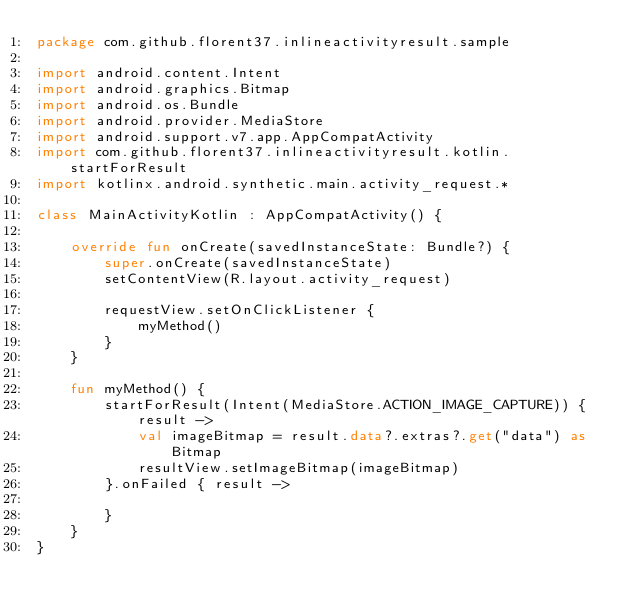<code> <loc_0><loc_0><loc_500><loc_500><_Kotlin_>package com.github.florent37.inlineactivityresult.sample

import android.content.Intent
import android.graphics.Bitmap
import android.os.Bundle
import android.provider.MediaStore
import android.support.v7.app.AppCompatActivity
import com.github.florent37.inlineactivityresult.kotlin.startForResult
import kotlinx.android.synthetic.main.activity_request.*

class MainActivityKotlin : AppCompatActivity() {

    override fun onCreate(savedInstanceState: Bundle?) {
        super.onCreate(savedInstanceState)
        setContentView(R.layout.activity_request)

        requestView.setOnClickListener {
            myMethod()
        }
    }

    fun myMethod() {
        startForResult(Intent(MediaStore.ACTION_IMAGE_CAPTURE)) { result ->
            val imageBitmap = result.data?.extras?.get("data") as Bitmap
            resultView.setImageBitmap(imageBitmap)
        }.onFailed { result ->

        }
    }
}</code> 